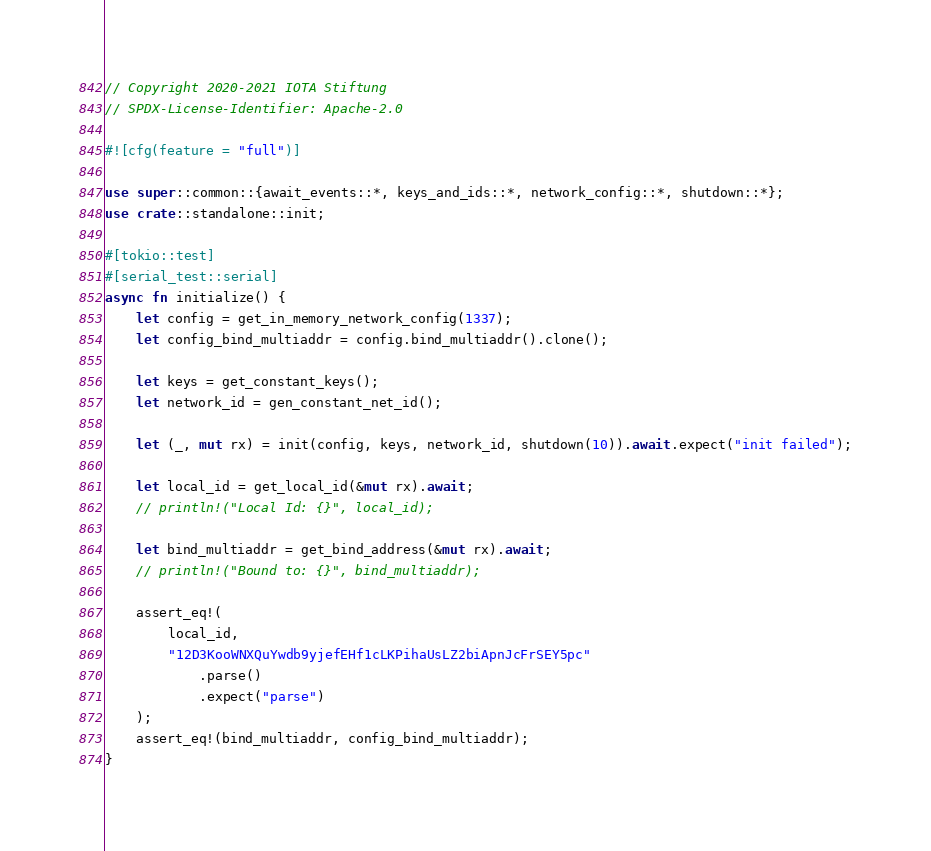Convert code to text. <code><loc_0><loc_0><loc_500><loc_500><_Rust_>// Copyright 2020-2021 IOTA Stiftung
// SPDX-License-Identifier: Apache-2.0

#![cfg(feature = "full")]

use super::common::{await_events::*, keys_and_ids::*, network_config::*, shutdown::*};
use crate::standalone::init;

#[tokio::test]
#[serial_test::serial]
async fn initialize() {
    let config = get_in_memory_network_config(1337);
    let config_bind_multiaddr = config.bind_multiaddr().clone();

    let keys = get_constant_keys();
    let network_id = gen_constant_net_id();

    let (_, mut rx) = init(config, keys, network_id, shutdown(10)).await.expect("init failed");

    let local_id = get_local_id(&mut rx).await;
    // println!("Local Id: {}", local_id);

    let bind_multiaddr = get_bind_address(&mut rx).await;
    // println!("Bound to: {}", bind_multiaddr);

    assert_eq!(
        local_id,
        "12D3KooWNXQuYwdb9yjefEHf1cLKPihaUsLZ2biApnJcFrSEY5pc"
            .parse()
            .expect("parse")
    );
    assert_eq!(bind_multiaddr, config_bind_multiaddr);
}
</code> 